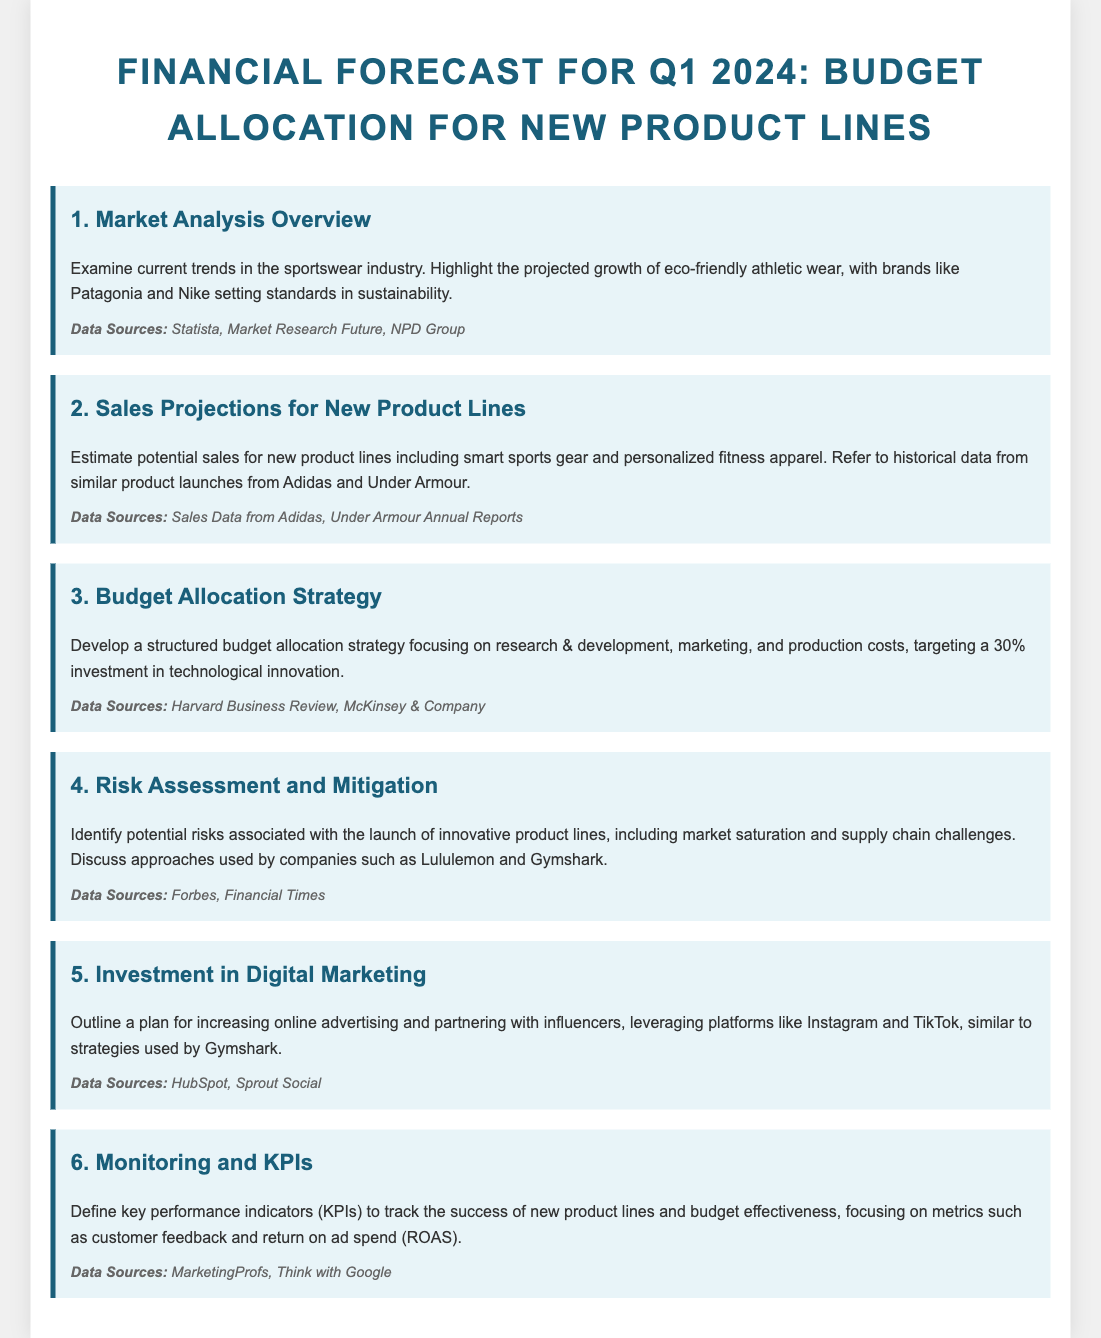What is the focus of the market analysis overview? The focus of the market analysis overview is on current trends in the sportswear industry, specifically the projected growth of eco-friendly athletic wear.
Answer: Eco-friendly athletic wear What percentage of investment is targeted for technological innovation? The targeted investment in technological innovation is specified in the budget allocation strategy section.
Answer: 30% Which companies are referenced for sales projections of new product lines? The sales projections for new product lines reference historical data from similar product launches from notable competitors.
Answer: Adidas and Under Armour What is one approach discussed for risk assessment related to new product launches? The document mentions discussing approaches used by specific companies regarding potential risks in the launch of innovative product lines.
Answer: Lululemon and Gymshark What type of marketing is emphasized in the investment section? The section on investment in digital marketing outlines plans for increasing a specific type of advertising and partnerships.
Answer: Online advertising 